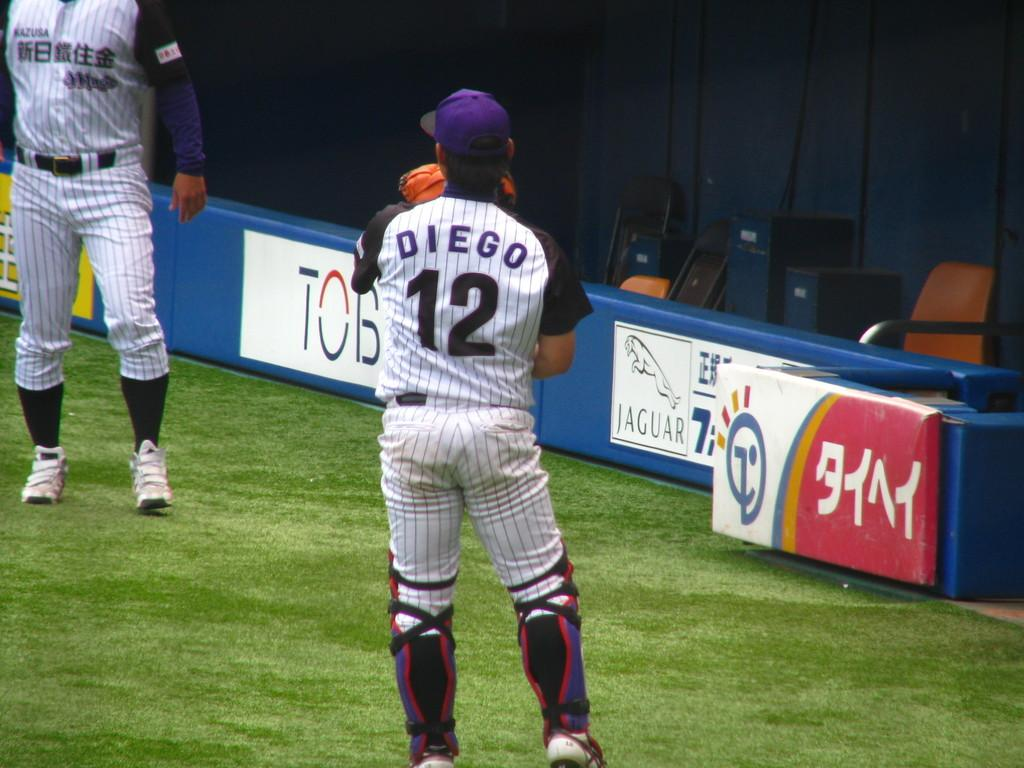<image>
Give a short and clear explanation of the subsequent image. a man with Diego on the back of his jersey 